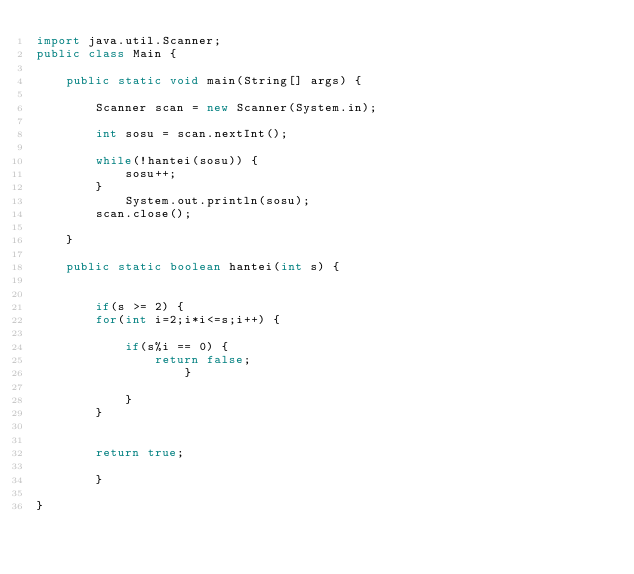Convert code to text. <code><loc_0><loc_0><loc_500><loc_500><_Java_>import java.util.Scanner;
public class Main {

	public static void main(String[] args) {

		Scanner scan = new Scanner(System.in);

		int sosu = scan.nextInt();

		while(!hantei(sosu)) {
			sosu++;
		}
			System.out.println(sosu);
		scan.close();

	}

	public static boolean hantei(int s) {


		if(s >= 2) {
		for(int i=2;i*i<=s;i++) {

			if(s%i == 0) {
				return false;
					}

			}
		}


		return true;

		}

}
</code> 